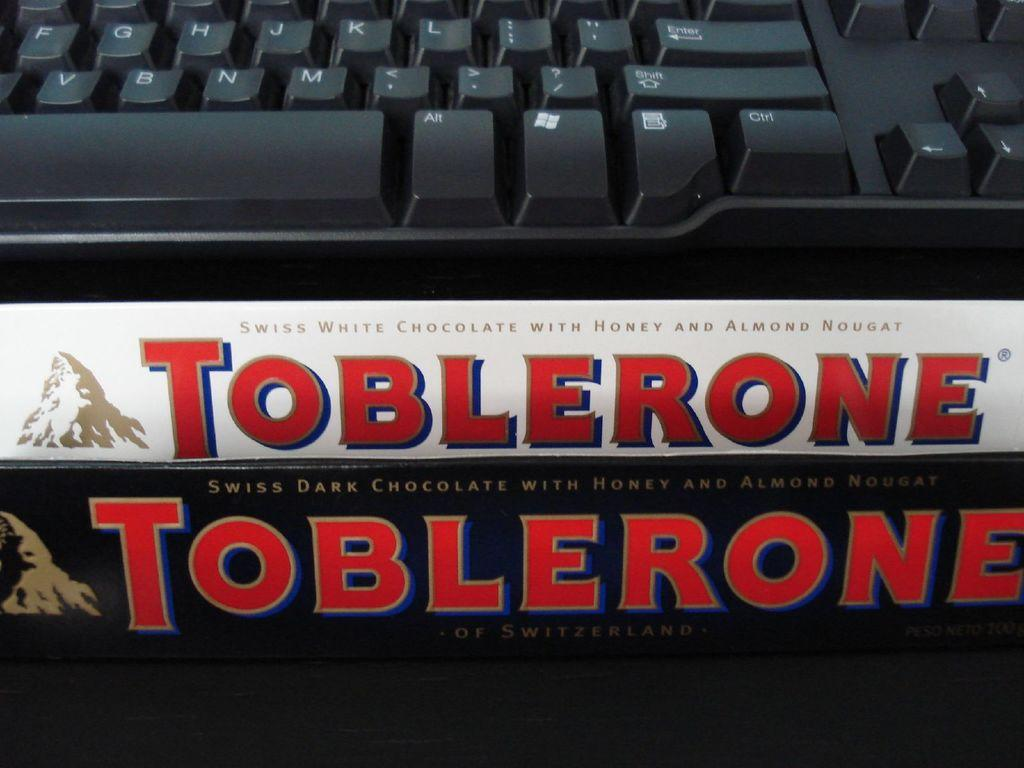Provide a one-sentence caption for the provided image. In front of the keyboard there is a white chocolate bar from Toblerone. 